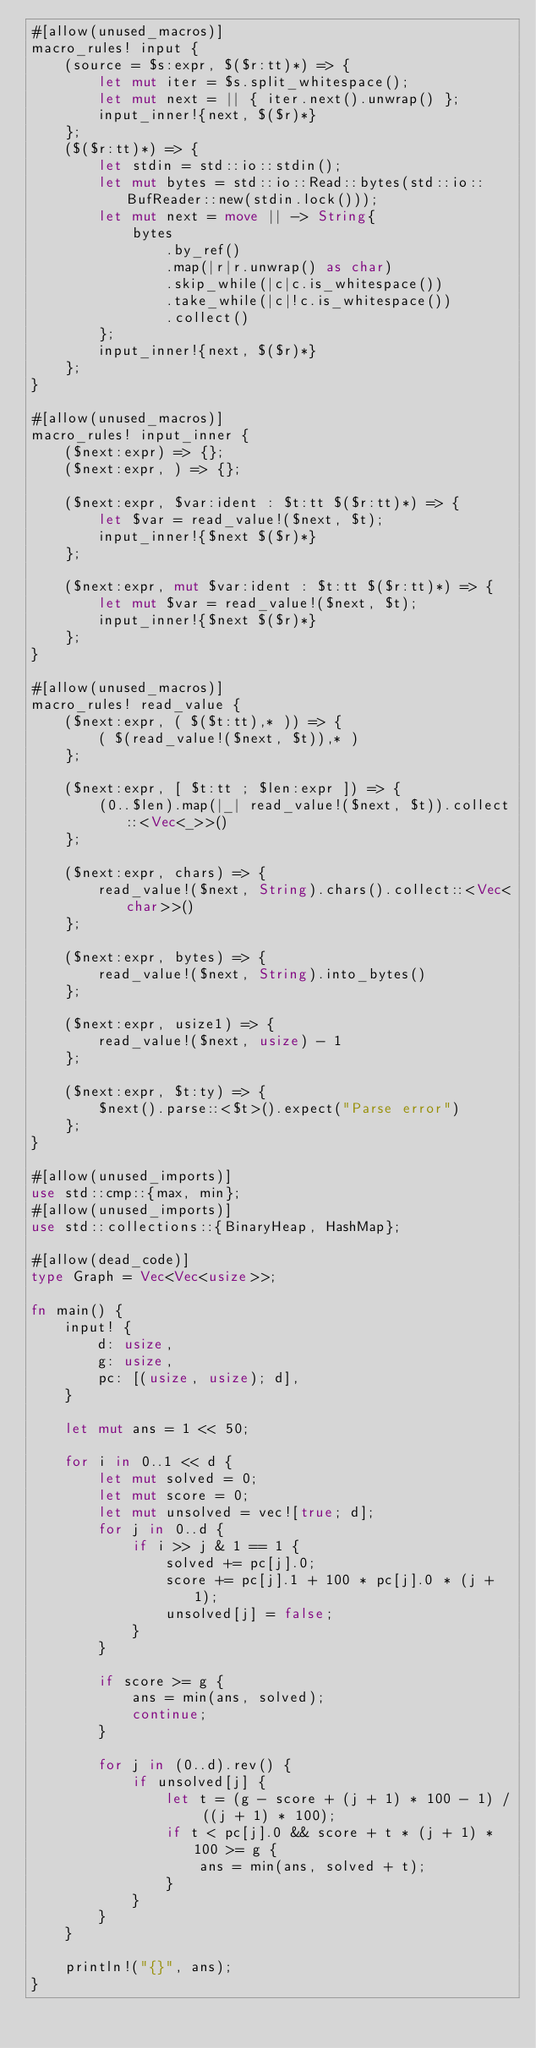Convert code to text. <code><loc_0><loc_0><loc_500><loc_500><_Rust_>#[allow(unused_macros)]
macro_rules! input {
    (source = $s:expr, $($r:tt)*) => {
        let mut iter = $s.split_whitespace();
        let mut next = || { iter.next().unwrap() };
        input_inner!{next, $($r)*}
    };
    ($($r:tt)*) => {
        let stdin = std::io::stdin();
        let mut bytes = std::io::Read::bytes(std::io::BufReader::new(stdin.lock()));
        let mut next = move || -> String{
            bytes
                .by_ref()
                .map(|r|r.unwrap() as char)
                .skip_while(|c|c.is_whitespace())
                .take_while(|c|!c.is_whitespace())
                .collect()
        };
        input_inner!{next, $($r)*}
    };
}

#[allow(unused_macros)]
macro_rules! input_inner {
    ($next:expr) => {};
    ($next:expr, ) => {};

    ($next:expr, $var:ident : $t:tt $($r:tt)*) => {
        let $var = read_value!($next, $t);
        input_inner!{$next $($r)*}
    };

    ($next:expr, mut $var:ident : $t:tt $($r:tt)*) => {
        let mut $var = read_value!($next, $t);
        input_inner!{$next $($r)*}
    };
}

#[allow(unused_macros)]
macro_rules! read_value {
    ($next:expr, ( $($t:tt),* )) => {
        ( $(read_value!($next, $t)),* )
    };

    ($next:expr, [ $t:tt ; $len:expr ]) => {
        (0..$len).map(|_| read_value!($next, $t)).collect::<Vec<_>>()
    };

    ($next:expr, chars) => {
        read_value!($next, String).chars().collect::<Vec<char>>()
    };

    ($next:expr, bytes) => {
        read_value!($next, String).into_bytes()
    };

    ($next:expr, usize1) => {
        read_value!($next, usize) - 1
    };

    ($next:expr, $t:ty) => {
        $next().parse::<$t>().expect("Parse error")
    };
}

#[allow(unused_imports)]
use std::cmp::{max, min};
#[allow(unused_imports)]
use std::collections::{BinaryHeap, HashMap};

#[allow(dead_code)]
type Graph = Vec<Vec<usize>>;

fn main() {
    input! {
        d: usize,
        g: usize,
        pc: [(usize, usize); d],
    }

    let mut ans = 1 << 50;

    for i in 0..1 << d {
        let mut solved = 0;
        let mut score = 0;
        let mut unsolved = vec![true; d];
        for j in 0..d {
            if i >> j & 1 == 1 {
                solved += pc[j].0;
                score += pc[j].1 + 100 * pc[j].0 * (j + 1);
                unsolved[j] = false;
            }
        }

        if score >= g {
            ans = min(ans, solved);
            continue;
        }

        for j in (0..d).rev() {
            if unsolved[j] {
                let t = (g - score + (j + 1) * 100 - 1) / ((j + 1) * 100);
                if t < pc[j].0 && score + t * (j + 1) * 100 >= g {
                    ans = min(ans, solved + t);
                }
            }
        }
    }

    println!("{}", ans);
}
</code> 